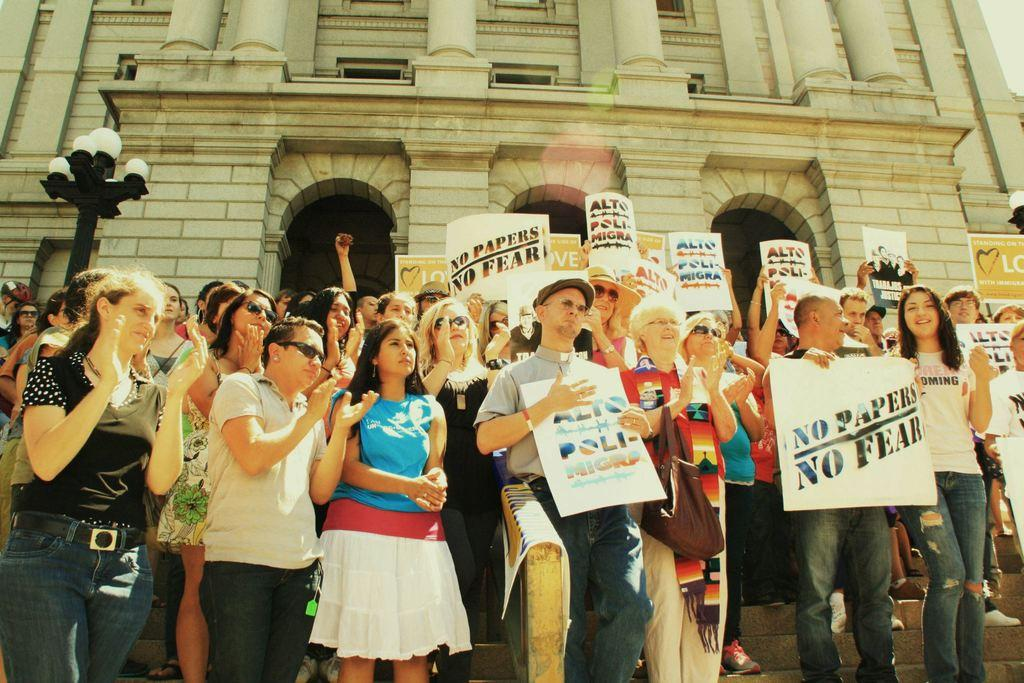What is happening in the image involving the group of people? Some people are holding placards in the image. What can be seen in the background of the image? There are lights, a building, and a pole visible in the background. What type of wine is being served at the event in the image? There is no event or wine present in the image; it features a group of people holding placards. What kind of box can be seen on the pole in the background? There is no box present on the pole in the background of the image. 